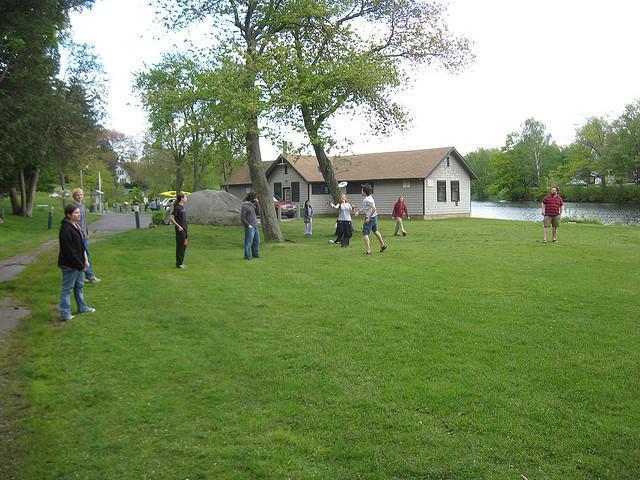How many people have red shirts?
Give a very brief answer. 2. How many buildings are visible?
Give a very brief answer. 1. 